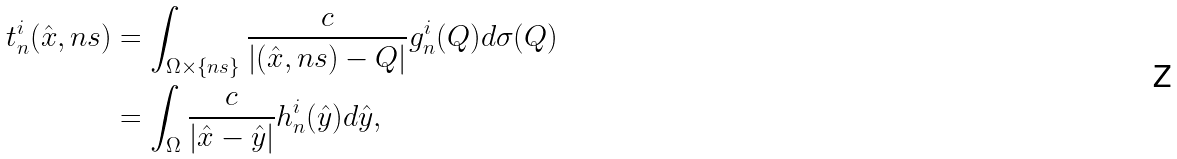<formula> <loc_0><loc_0><loc_500><loc_500>t _ { n } ^ { i } ( \hat { x } , n s ) & = \int _ { \Omega \times \{ n s \} } \frac { c } { | ( \hat { x } , n s ) - Q | } g _ { n } ^ { i } ( Q ) d \sigma ( Q ) \\ & = \int _ { \Omega } \frac { c } { | \hat { x } - \hat { y } | } h _ { n } ^ { i } ( \hat { y } ) d \hat { y } ,</formula> 